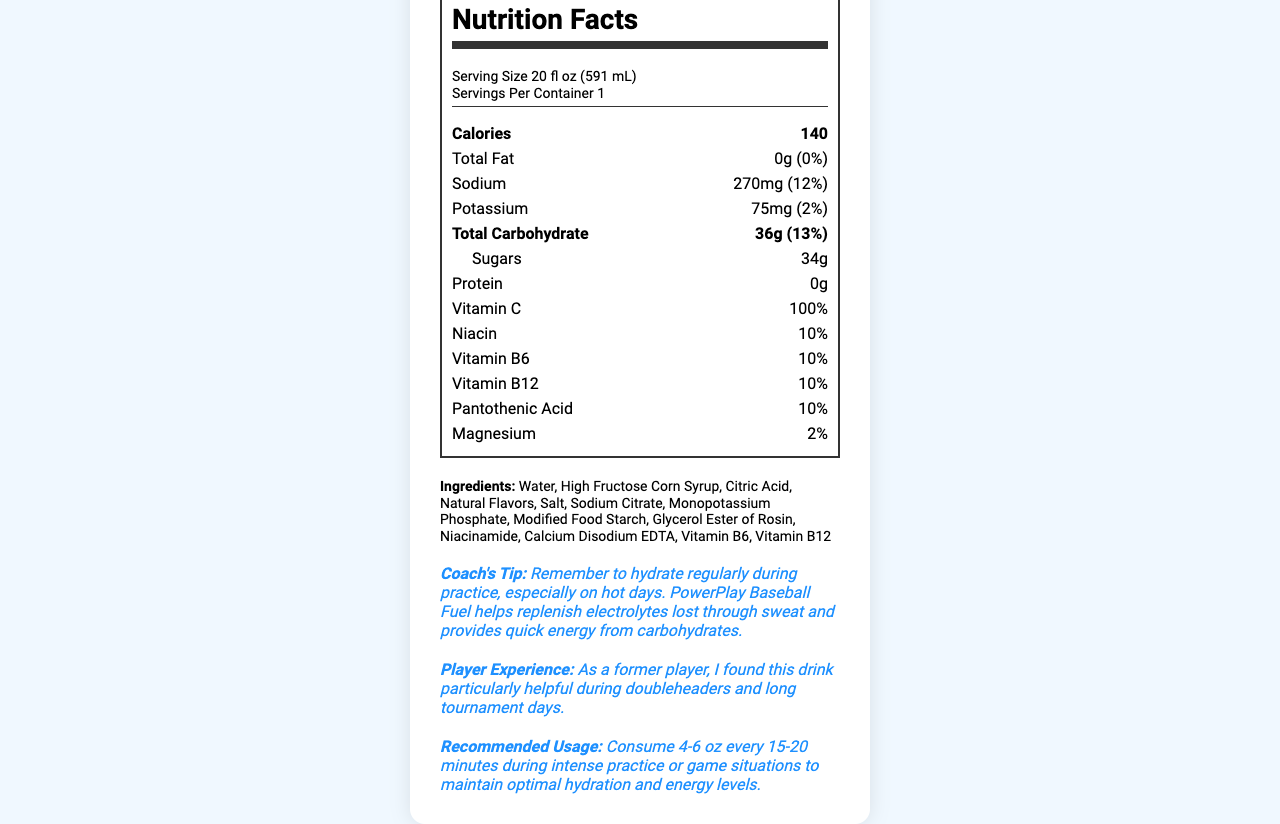what is the serving size for PowerPlay Baseball Fuel? The serving size is explicitly stated at the top of the nutrition label as "Serving Size 20 fl oz (591 mL)".
Answer: 20 fl oz (591 mL) how many calories are in one serving of PowerPlay Baseball Fuel? The calories per serving are clearly listed as "Calories 140" in the nutrition facts section.
Answer: 140 calories how much sodium does each serving contain? The sodium content is listed in the nutrition facts section as "Sodium 270mg".
Answer: 270mg how many grams of sugars are in one serving? The sugars content is found under the total carbohydrate section of the nutrition facts as "Sugars 34g".
Answer: 34g what percentage of daily Vitamin C does PowerPlay Baseball Fuel provide? The document states that the drink provides 100% of the daily value for Vitamin C.
Answer: 100% which electrolyte does PowerPlay Baseball Fuel contain the most of? A. Sodium B. Potassium C. Magnesium D. Calcium The sodium content is 270mg, whereas potassium is 75mg and magnesium is 2% of daily value. There is no calcium listed.
Answer: A. Sodium how many servings are in each container of PowerPlay Baseball Fuel? The servings per container are listed as 1 in the nutrition facts label.
Answer: 1 which vitamins play a role in energy metabolism provided by this drink? A. Vitamin C B. Niacin C. Vitamin B6 D. All of the above The vitamins listed in the document that are involved in energy metabolism include Vitamin C, Niacin, and Vitamin B6.
Answer: D. All of the above Is PowerPlay Baseball Fuel a good source of protein? The protein content is listed as 0g, indicating it contains no protein.
Answer: No describe the main purpose of PowerPlay Baseball Fuel based on the document The document highlights that the drink contains essential electrolytes like sodium and potassium, significant amounts of carbohydrates, and provides energy and hydration needed for intense physical activities.
Answer: The main purpose of PowerPlay Baseball Fuel is to help replenish electrolytes lost through sweat and provide quick energy from carbohydrates. This is especially beneficial for maintaining optimal hydration and energy levels during intense baseball practice or games. how many grams of total fat are in one serving? The nutrition facts section lists the total fat content as "0g".
Answer: 0g what are the natural flavors used in PowerPlay Baseball Fuel? The document lists "Natural Flavors" in the ingredients but does not specify what those flavors are.
Answer: Cannot be determined how should PowerPlay Baseball Fuel be consumed for optimal results during practice? The document's recommended usage section advises consuming 4-6 oz every 15-20 minutes during intense activities.
Answer: Consume 4-6 oz every 15-20 minutes during intense practice or game situations. what is the coach's tip regarding the consumption of PowerPlay Baseball Fuel? The coach's tip section provides advice on regular hydration during practice, mentioning the benefits of the drink.
Answer: Remember to hydrate regularly during practice, especially on hot days. PowerPlay Baseball Fuel helps replenish electrolytes lost through sweat and provides quick energy from carbohydrates. what is the ingredient used in PowerPlay Baseball Fuel to maintain color and flavor stability? A. Sodium Citrate B. Calcium Disodium EDTA C. Citric Acid D. High Fructose Corn Syrup The ingredient list includes Calcium Disodium EDTA, which is commonly used to maintain color and flavor stability in beverages.
Answer: B. Calcium Disodium EDTA 